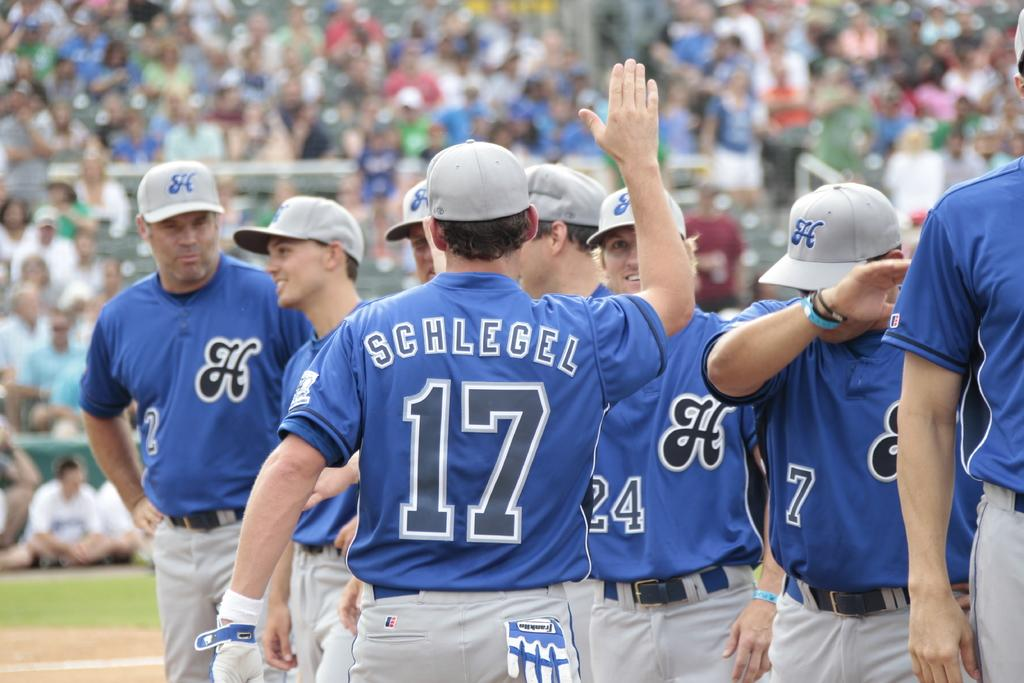Provide a one-sentence caption for the provided image. The player facing away from the camera is number 17. 